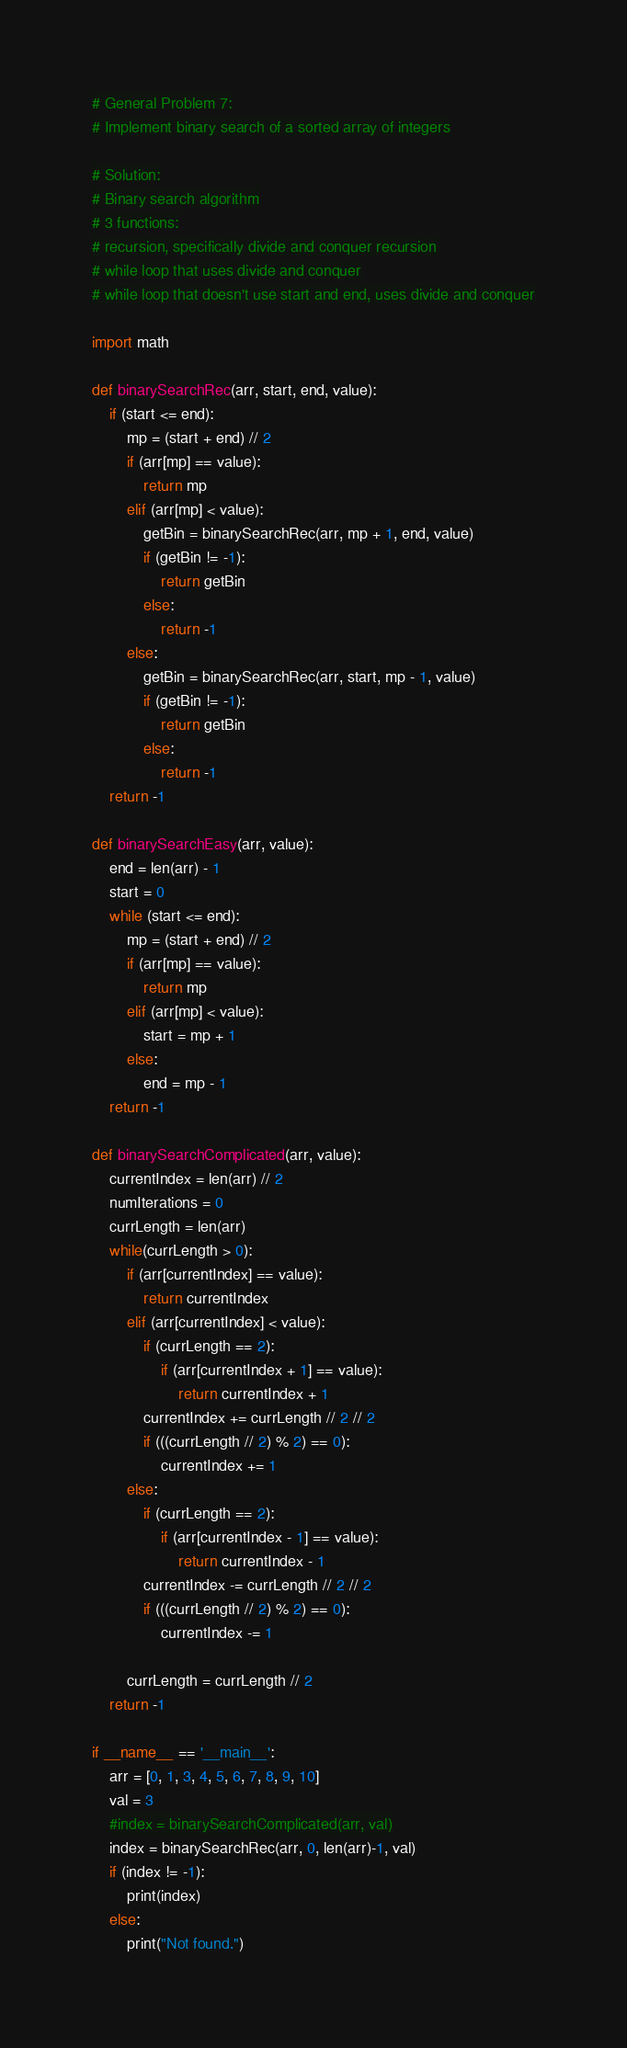<code> <loc_0><loc_0><loc_500><loc_500><_Python_># General Problem 7:
# Implement binary search of a sorted array of integers

# Solution:
# Binary search algorithm
# 3 functions:
# recursion, specifically divide and conquer recursion
# while loop that uses divide and conquer
# while loop that doesn't use start and end, uses divide and conquer

import math

def binarySearchRec(arr, start, end, value):
	if (start <= end):
		mp = (start + end) // 2
		if (arr[mp] == value):
			return mp
		elif (arr[mp] < value):
			getBin = binarySearchRec(arr, mp + 1, end, value)
			if (getBin != -1):
				return getBin
			else:
				return -1
		else:
			getBin = binarySearchRec(arr, start, mp - 1, value)
			if (getBin != -1):
				return getBin
			else:
				return -1
	return -1

def binarySearchEasy(arr, value):
	end = len(arr) - 1
	start = 0
	while (start <= end):
		mp = (start + end) // 2
		if (arr[mp] == value):
			return mp
		elif (arr[mp] < value):
			start = mp + 1
		else:
			end = mp - 1
	return -1

def binarySearchComplicated(arr, value):
	currentIndex = len(arr) // 2
	numIterations = 0
	currLength = len(arr)
	while(currLength > 0):
		if (arr[currentIndex] == value):
			return currentIndex
		elif (arr[currentIndex] < value):
			if (currLength == 2):
				if (arr[currentIndex + 1] == value):
					return currentIndex + 1
			currentIndex += currLength // 2 // 2
			if (((currLength // 2) % 2) == 0):
				currentIndex += 1
		else:
			if (currLength == 2):
				if (arr[currentIndex - 1] == value):
					return currentIndex - 1
			currentIndex -= currLength // 2 // 2
			if (((currLength // 2) % 2) == 0):
				currentIndex -= 1

		currLength = currLength // 2
	return -1

if __name__ == '__main__':
	arr = [0, 1, 3, 4, 5, 6, 7, 8, 9, 10]
	val = 3
	#index = binarySearchComplicated(arr, val)
	index = binarySearchRec(arr, 0, len(arr)-1, val)
	if (index != -1):
		print(index)
	else:
		print("Not found.")
</code> 